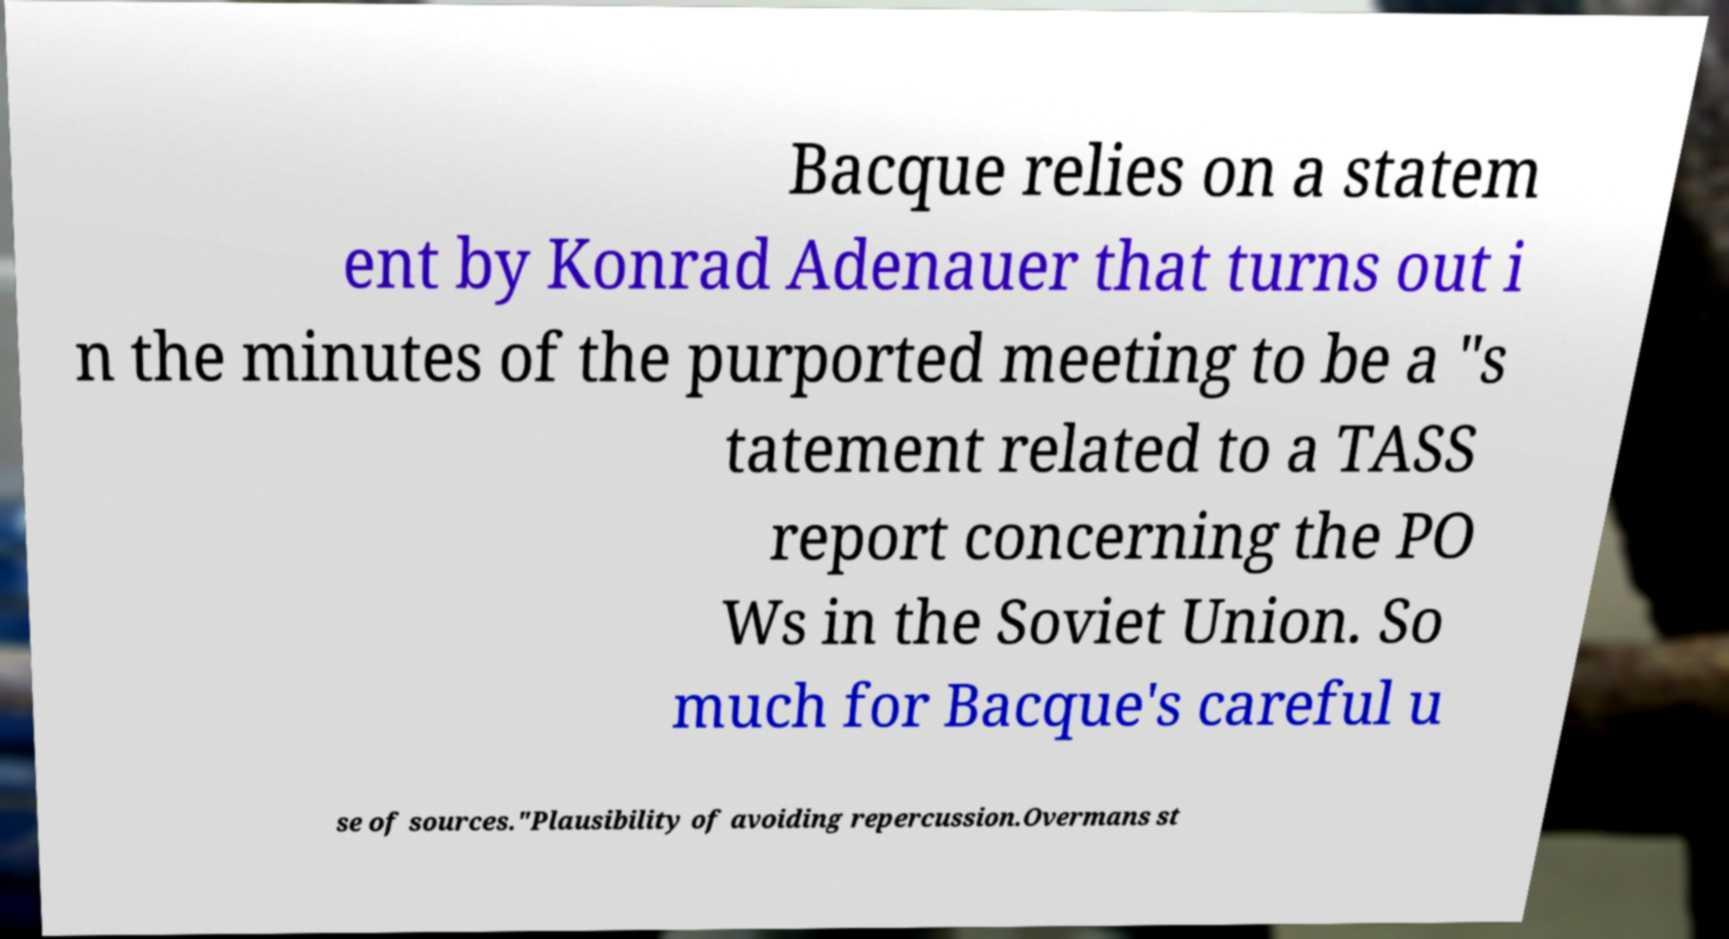Could you assist in decoding the text presented in this image and type it out clearly? Bacque relies on a statem ent by Konrad Adenauer that turns out i n the minutes of the purported meeting to be a "s tatement related to a TASS report concerning the PO Ws in the Soviet Union. So much for Bacque's careful u se of sources."Plausibility of avoiding repercussion.Overmans st 